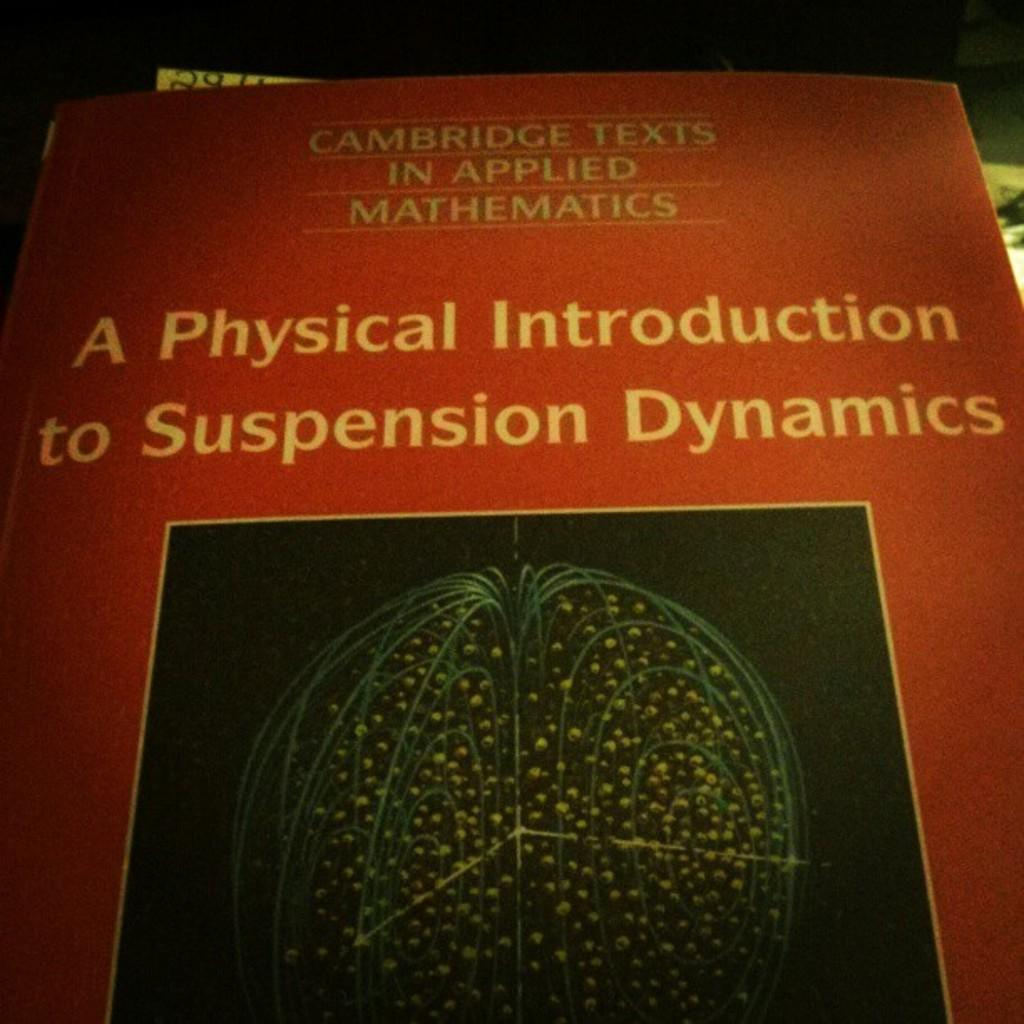<image>
Render a clear and concise summary of the photo. A book titled A Physical Introduction to Suspension Dynamics. 